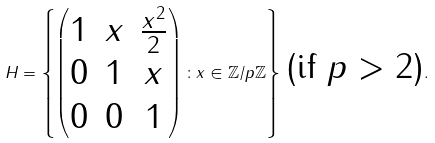<formula> <loc_0><loc_0><loc_500><loc_500>H = \left \{ \left ( \begin{matrix} 1 & x & \frac { x ^ { 2 } } { 2 } \\ 0 & 1 & x \\ 0 & 0 & 1 \end{matrix} \right ) \colon x \in \mathbb { Z } / p \mathbb { Z } \right \} \, \text {(if $p>2$)} .</formula> 